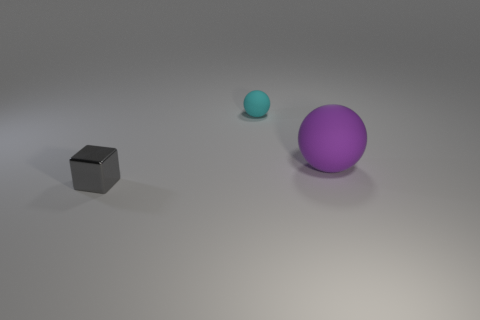Can you describe the lighting in the scene? The lighting in the image gives off a diffuse appearance, possibly from an overhead source. There are soft shadows extending from the objects, indicating the light is not extremely harsh or direct, creating a calm and even tone across the scene. 